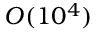Convert formula to latex. <formula><loc_0><loc_0><loc_500><loc_500>O ( 1 0 ^ { 4 } )</formula> 